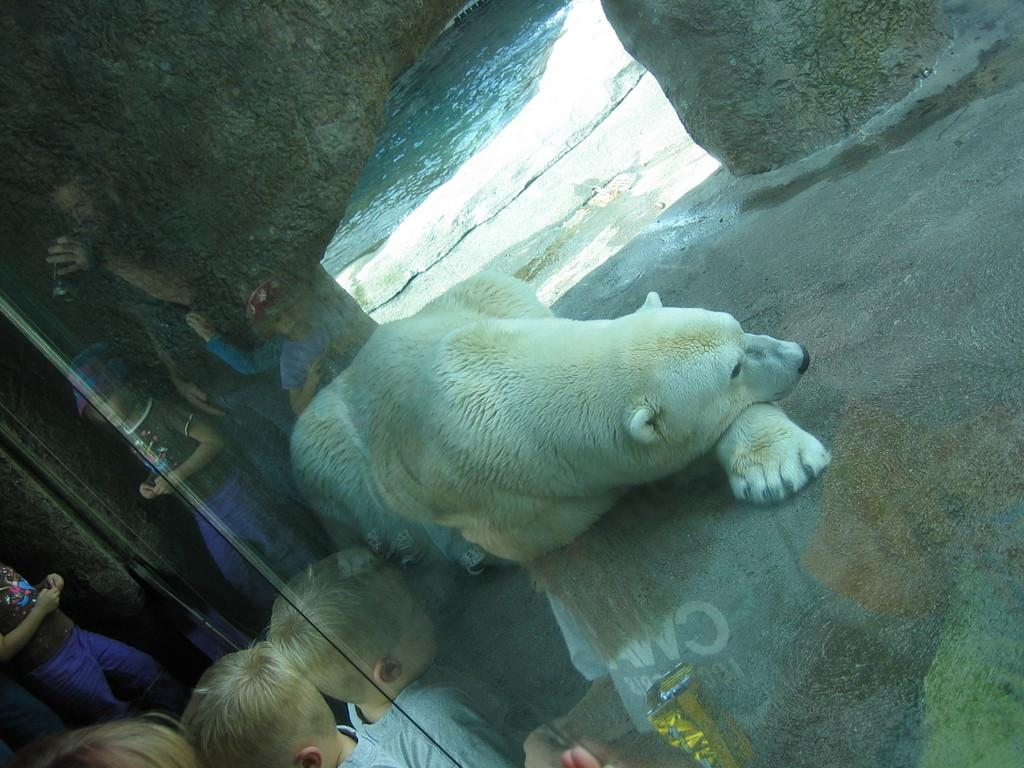What type of animal is in the image? There is a polar bear in the image. What is the primary element visible in the image? Water is visible in the image. What type of natural formation can be seen in the image? There are rocks in the image. What architectural feature is present in the image? There is a glass door in the image. What can be observed on the glass door? The reflection of people standing is visible on the glass door. What type of boundary can be seen in the image? There is no boundary present in the image. What type of magic is being performed by the polar bear in the image? There is no magic or magical activity depicted in the image. 